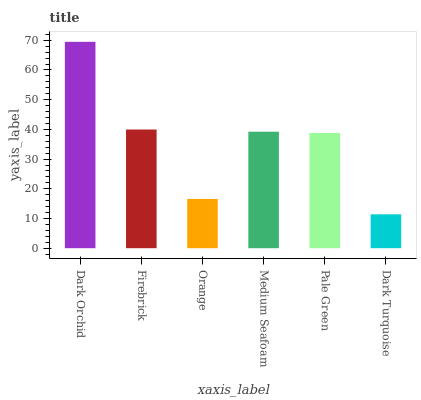Is Dark Turquoise the minimum?
Answer yes or no. Yes. Is Dark Orchid the maximum?
Answer yes or no. Yes. Is Firebrick the minimum?
Answer yes or no. No. Is Firebrick the maximum?
Answer yes or no. No. Is Dark Orchid greater than Firebrick?
Answer yes or no. Yes. Is Firebrick less than Dark Orchid?
Answer yes or no. Yes. Is Firebrick greater than Dark Orchid?
Answer yes or no. No. Is Dark Orchid less than Firebrick?
Answer yes or no. No. Is Medium Seafoam the high median?
Answer yes or no. Yes. Is Pale Green the low median?
Answer yes or no. Yes. Is Firebrick the high median?
Answer yes or no. No. Is Firebrick the low median?
Answer yes or no. No. 